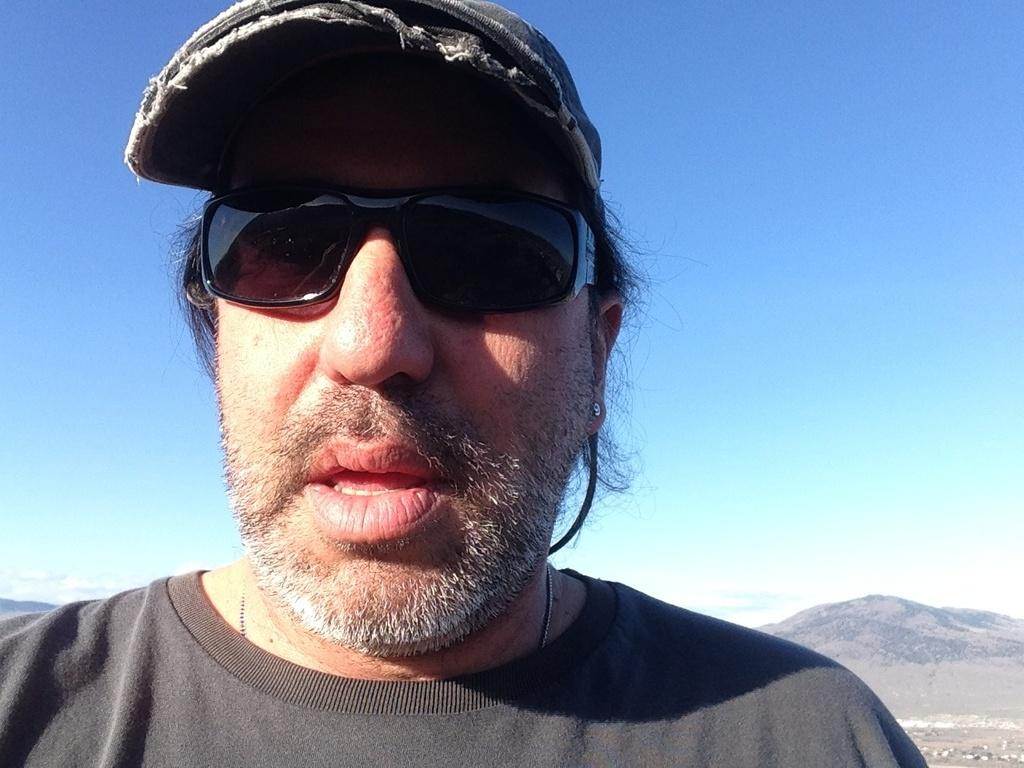Who is present in the image? There is a man in the image. What is the man wearing on his upper body? The man is wearing a black t-shirt. What protective gear is the man wearing? The man is wearing goggles. What type of headwear is the man wearing? The man is wearing a cap. What can be seen in the distance in the image? There are mountains visible in the background of the image. What else is visible in the background of the image? The sky is visible in the background of the image. Can you tell me how many snails are crawling on the man's cap in the image? There are no snails present on the man's cap in the image. What type of exchange is taking place between the man and the mountains in the image? There is no exchange taking place between the man and the mountains in the image; they are simply visible in the background. 